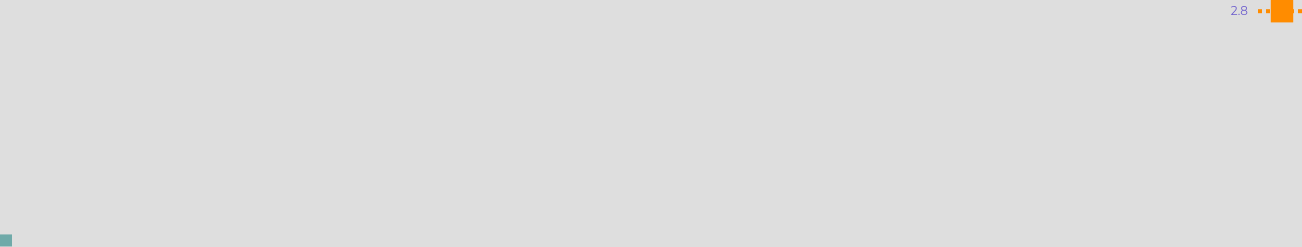Convert chart to OTSL. <chart><loc_0><loc_0><loc_500><loc_500><line_chart><ecel><fcel>2.8<nl><fcel>1737.47<fcel>259.24<nl><fcel>2348.35<fcel>231.23<nl><fcel>2414.7<fcel>511.32<nl></chart> 